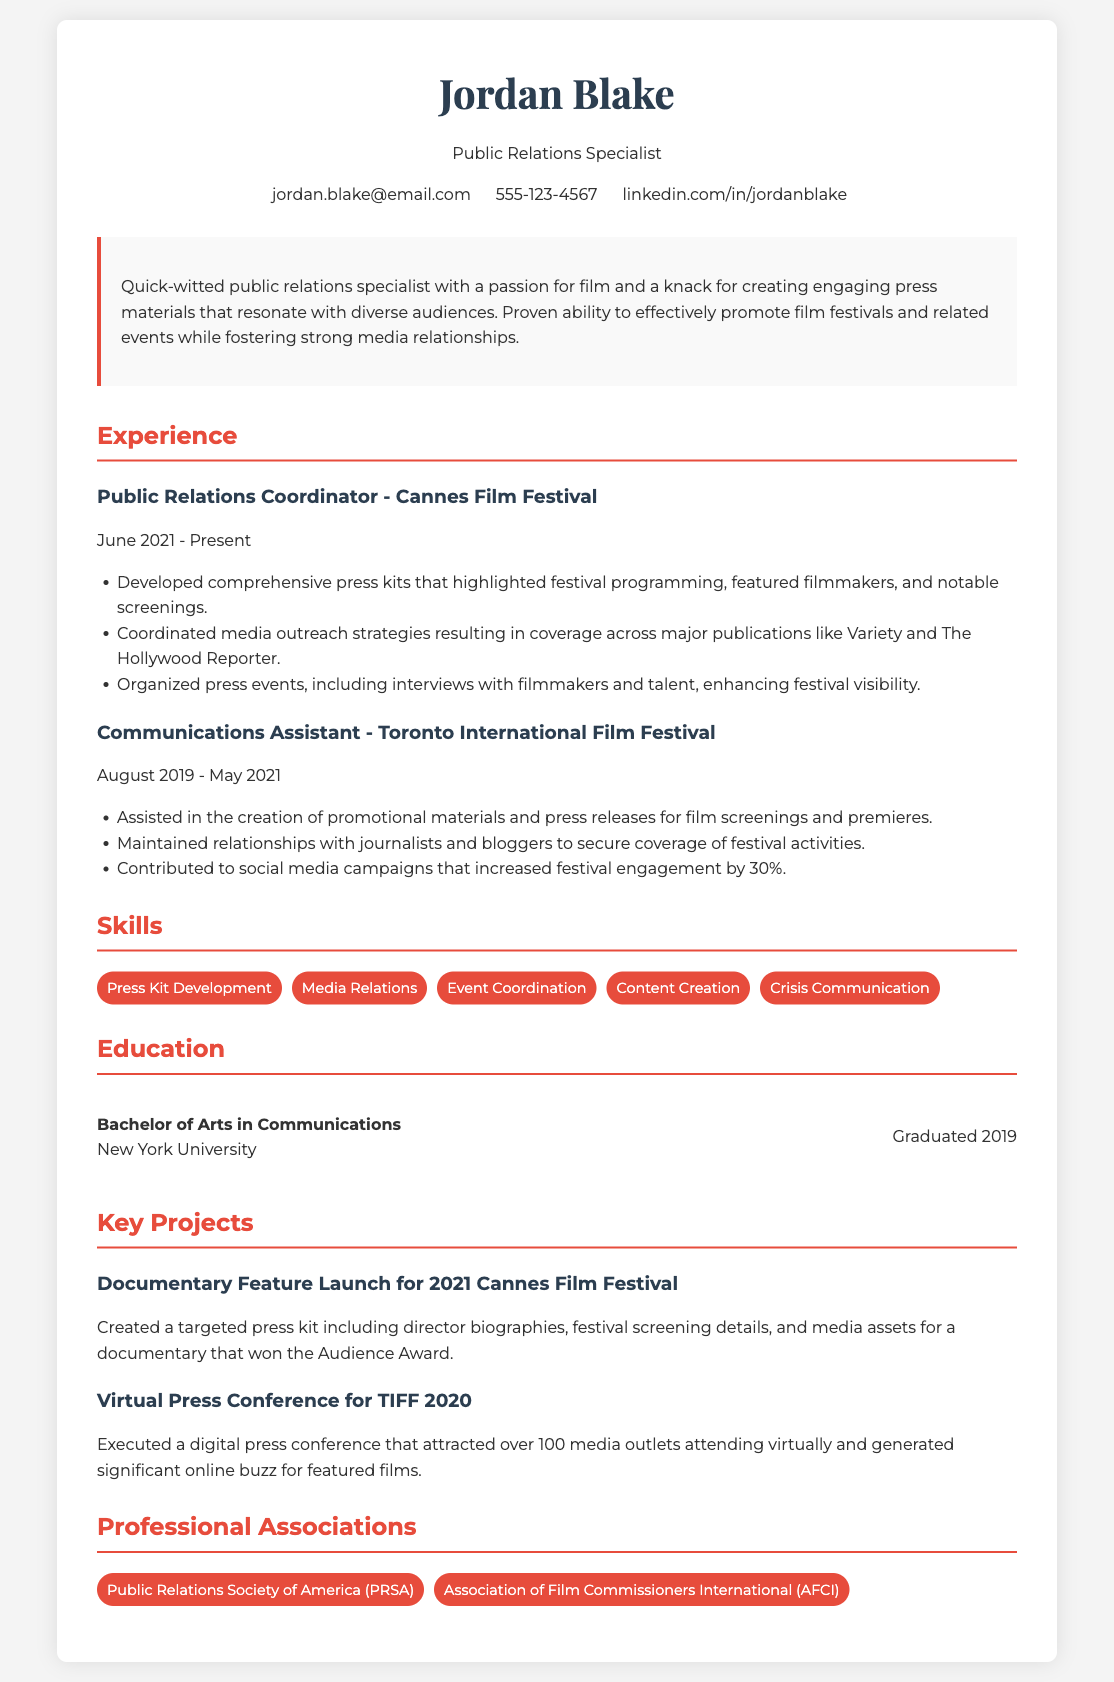What is Jordan Blake's profession? The document specifies the profession listed at the top of the resume.
Answer: Public Relations Specialist Which film festival does Jordan currently work for? The document mentions the organization where Jordan is presently employed.
Answer: Cannes Film Festival What degree did Jordan Blake earn? The education section lists the degree obtained by Jordan.
Answer: Bachelor of Arts in Communications When did Jordan start working at Cannes Film Festival? The experience section includes the starting date of this position.
Answer: June 2021 How many years did Jordan work at Toronto International Film Festival? To find this, we calculate the time between the end date and start date of the position.
Answer: 1.75 years What is one skill listed in the skills section? The skills section enumerates specific skills held by Jordan.
Answer: Press Kit Development Which award did the documentary featured in Jordan's project win? The project section mentions the award received by the documentary associated with the Cannes Film Festival.
Answer: Audience Award What was the increase in festival engagement attributed to social media campaigns? The document notes the percentage increase resulting from Jordan's efforts in this area.
Answer: 30% 